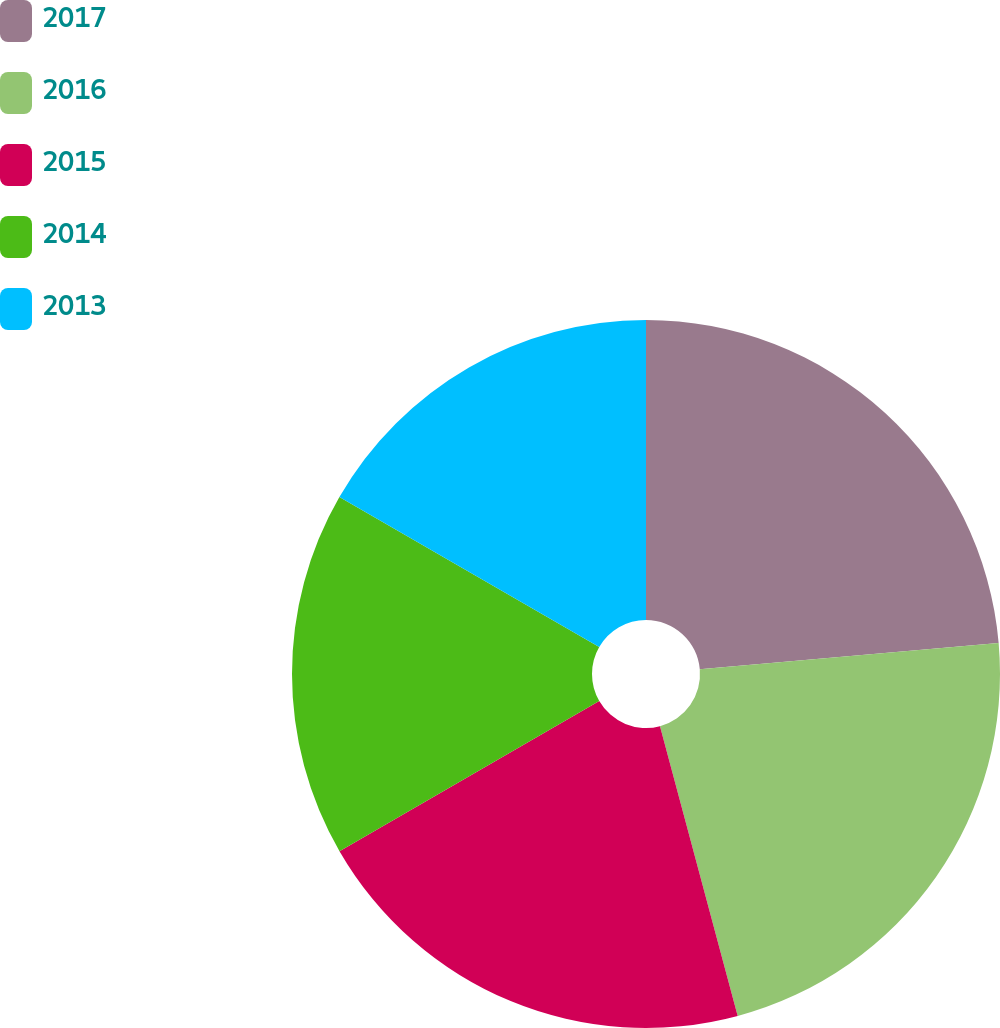Convert chart to OTSL. <chart><loc_0><loc_0><loc_500><loc_500><pie_chart><fcel>2017<fcel>2016<fcel>2015<fcel>2014<fcel>2013<nl><fcel>23.61%<fcel>22.22%<fcel>20.83%<fcel>16.67%<fcel>16.67%<nl></chart> 